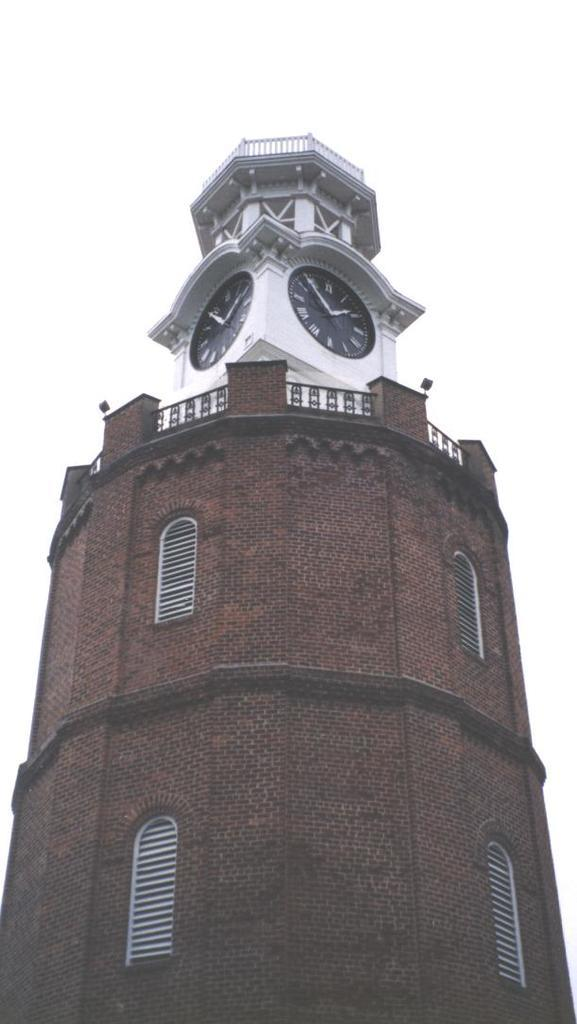What is the main structure in the image? There is a brown and white tower in the image. What can be seen on the tower? Clocks are visible in the image. What allows light to enter the tower? There are windows in the image. What color is the background of the image? The background of the image is white. What type of yoke is used to carry the tomatoes in the image? There are no tomatoes or yokes present in the image. 